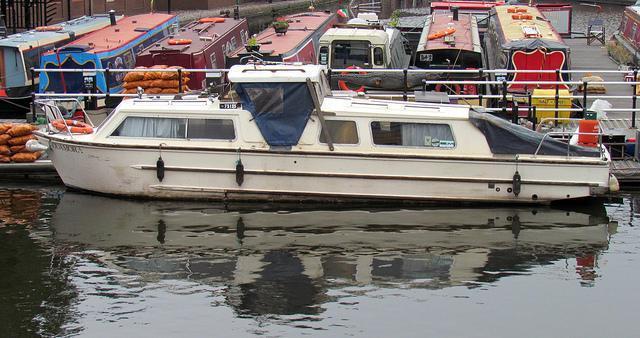How many boats are in this scene?
Give a very brief answer. 1. How many boats can you see?
Give a very brief answer. 5. How many people are wearing coats?
Give a very brief answer. 0. 